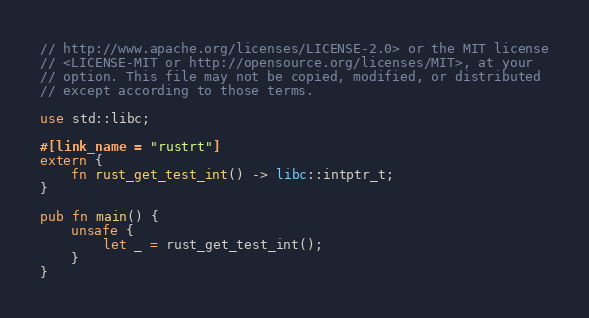<code> <loc_0><loc_0><loc_500><loc_500><_Rust_>// http://www.apache.org/licenses/LICENSE-2.0> or the MIT license
// <LICENSE-MIT or http://opensource.org/licenses/MIT>, at your
// option. This file may not be copied, modified, or distributed
// except according to those terms.

use std::libc;

#[link_name = "rustrt"]
extern {
    fn rust_get_test_int() -> libc::intptr_t;
}

pub fn main() {
    unsafe {
        let _ = rust_get_test_int();
    }
}
</code> 